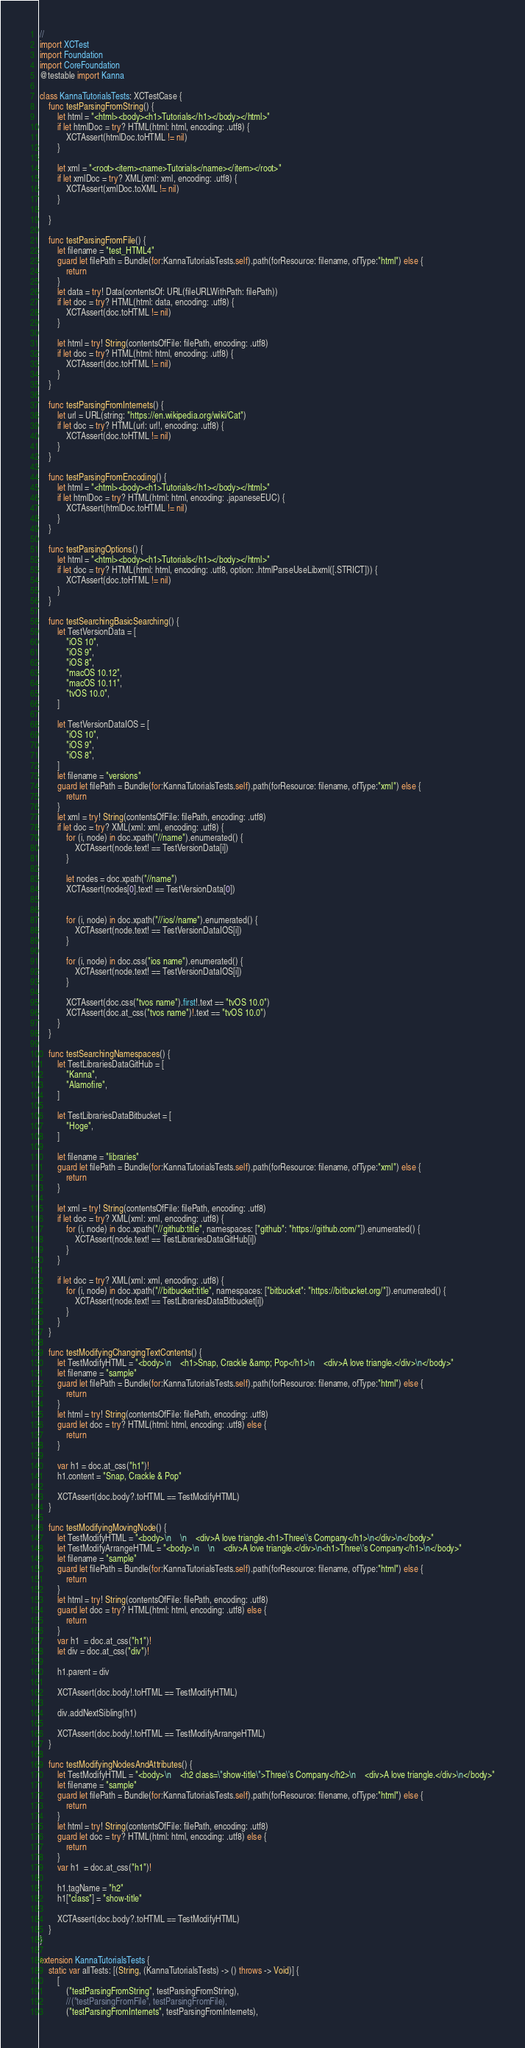<code> <loc_0><loc_0><loc_500><loc_500><_Swift_>//
import XCTest
import Foundation
import CoreFoundation
@testable import Kanna

class KannaTutorialsTests: XCTestCase {
    func testParsingFromString() {
        let html = "<html><body><h1>Tutorials</h1></body></html>"
        if let htmlDoc = try? HTML(html: html, encoding: .utf8) {
            XCTAssert(htmlDoc.toHTML != nil)
        }

        let xml = "<root><item><name>Tutorials</name></item></root>"
        if let xmlDoc = try? XML(xml: xml, encoding: .utf8) {
            XCTAssert(xmlDoc.toXML != nil)
        }

    }

    func testParsingFromFile() {
        let filename = "test_HTML4"
        guard let filePath = Bundle(for:KannaTutorialsTests.self).path(forResource: filename, ofType:"html") else {
            return
        }
        let data = try! Data(contentsOf: URL(fileURLWithPath: filePath))
        if let doc = try? HTML(html: data, encoding: .utf8) {
            XCTAssert(doc.toHTML != nil)
        }

        let html = try! String(contentsOfFile: filePath, encoding: .utf8)
        if let doc = try? HTML(html: html, encoding: .utf8) {
            XCTAssert(doc.toHTML != nil)
        }
    }

    func testParsingFromInternets() {
        let url = URL(string: "https://en.wikipedia.org/wiki/Cat")
        if let doc = try? HTML(url: url!, encoding: .utf8) {
            XCTAssert(doc.toHTML != nil)
        }
    }

    func testParsingFromEncoding() {
        let html = "<html><body><h1>Tutorials</h1></body></html>"
        if let htmlDoc = try? HTML(html: html, encoding: .japaneseEUC) {
            XCTAssert(htmlDoc.toHTML != nil)
        }
    }

    func testParsingOptions() {
        let html = "<html><body><h1>Tutorials</h1></body></html>"
        if let doc = try? HTML(html: html, encoding: .utf8, option: .htmlParseUseLibxml([.STRICT])) {
            XCTAssert(doc.toHTML != nil)
        }
    }

    func testSearchingBasicSearching() {
        let TestVersionData = [
            "iOS 10",
            "iOS 9",
            "iOS 8",
            "macOS 10.12",
            "macOS 10.11",
            "tvOS 10.0",
        ]

        let TestVersionDataIOS = [
            "iOS 10",
            "iOS 9",
            "iOS 8",
        ]
        let filename = "versions"
        guard let filePath = Bundle(for:KannaTutorialsTests.self).path(forResource: filename, ofType:"xml") else {
            return
        }
        let xml = try! String(contentsOfFile: filePath, encoding: .utf8)
        if let doc = try? XML(xml: xml, encoding: .utf8) {
            for (i, node) in doc.xpath("//name").enumerated() {
                XCTAssert(node.text! == TestVersionData[i])
            }

            let nodes = doc.xpath("//name")
            XCTAssert(nodes[0].text! == TestVersionData[0])


            for (i, node) in doc.xpath("//ios//name").enumerated() {
                XCTAssert(node.text! == TestVersionDataIOS[i])
            }

            for (i, node) in doc.css("ios name").enumerated() {
                XCTAssert(node.text! == TestVersionDataIOS[i])
            }

            XCTAssert(doc.css("tvos name").first!.text == "tvOS 10.0")
            XCTAssert(doc.at_css("tvos name")!.text == "tvOS 10.0")
        }
    }

    func testSearchingNamespaces() {
        let TestLibrariesDataGitHub = [
            "Kanna",
            "Alamofire",
        ]

        let TestLibrariesDataBitbucket = [
            "Hoge",
        ]

        let filename = "libraries"
        guard let filePath = Bundle(for:KannaTutorialsTests.self).path(forResource: filename, ofType:"xml") else {
            return
        }

        let xml = try! String(contentsOfFile: filePath, encoding: .utf8)
        if let doc = try? XML(xml: xml, encoding: .utf8) {
            for (i, node) in doc.xpath("//github:title", namespaces: ["github": "https://github.com/"]).enumerated() {
                XCTAssert(node.text! == TestLibrariesDataGitHub[i])
            }
        }

        if let doc = try? XML(xml: xml, encoding: .utf8) {
            for (i, node) in doc.xpath("//bitbucket:title", namespaces: ["bitbucket": "https://bitbucket.org/"]).enumerated() {
                XCTAssert(node.text! == TestLibrariesDataBitbucket[i])
            }
        }
    }

    func testModifyingChangingTextContents() {
        let TestModifyHTML = "<body>\n    <h1>Snap, Crackle &amp; Pop</h1>\n    <div>A love triangle.</div>\n</body>"
        let filename = "sample"
        guard let filePath = Bundle(for:KannaTutorialsTests.self).path(forResource: filename, ofType:"html") else {
            return
        }
        let html = try! String(contentsOfFile: filePath, encoding: .utf8)
        guard let doc = try? HTML(html: html, encoding: .utf8) else {
            return
        }

        var h1 = doc.at_css("h1")!
        h1.content = "Snap, Crackle & Pop"

        XCTAssert(doc.body?.toHTML == TestModifyHTML)
    }

    func testModifyingMovingNode() {
        let TestModifyHTML = "<body>\n    \n    <div>A love triangle.<h1>Three\'s Company</h1>\n</div>\n</body>"
        let TestModifyArrangeHTML = "<body>\n    \n    <div>A love triangle.</div>\n<h1>Three\'s Company</h1>\n</body>"
        let filename = "sample"
        guard let filePath = Bundle(for:KannaTutorialsTests.self).path(forResource: filename, ofType:"html") else {
            return
        }
        let html = try! String(contentsOfFile: filePath, encoding: .utf8)
        guard let doc = try? HTML(html: html, encoding: .utf8) else {
            return
        }
        var h1  = doc.at_css("h1")!
        let div = doc.at_css("div")!

        h1.parent = div

        XCTAssert(doc.body!.toHTML == TestModifyHTML)

        div.addNextSibling(h1)

        XCTAssert(doc.body!.toHTML == TestModifyArrangeHTML)
    }

    func testModifyingNodesAndAttributes() {
        let TestModifyHTML = "<body>\n    <h2 class=\"show-title\">Three\'s Company</h2>\n    <div>A love triangle.</div>\n</body>"
        let filename = "sample"
        guard let filePath = Bundle(for:KannaTutorialsTests.self).path(forResource: filename, ofType:"html") else {
            return
        }
        let html = try! String(contentsOfFile: filePath, encoding: .utf8)
        guard let doc = try? HTML(html: html, encoding: .utf8) else {
            return
        }
        var h1  = doc.at_css("h1")!

        h1.tagName = "h2"
        h1["class"] = "show-title"

        XCTAssert(doc.body?.toHTML == TestModifyHTML)
    }
}

extension KannaTutorialsTests {
    static var allTests: [(String, (KannaTutorialsTests) -> () throws -> Void)] {
        [
            ("testParsingFromString", testParsingFromString),
            //("testParsingFromFile", testParsingFromFile),
            ("testParsingFromInternets", testParsingFromInternets),</code> 